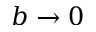<formula> <loc_0><loc_0><loc_500><loc_500>b \rightarrow 0</formula> 